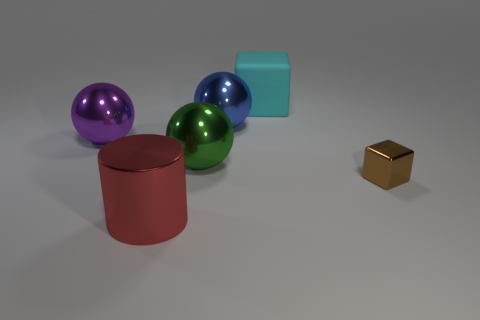Add 2 brown metal blocks. How many objects exist? 8 Subtract all cylinders. How many objects are left? 5 Subtract 0 blue cylinders. How many objects are left? 6 Subtract all big blue shiny cylinders. Subtract all big green metal spheres. How many objects are left? 5 Add 1 big objects. How many big objects are left? 6 Add 3 green matte objects. How many green matte objects exist? 3 